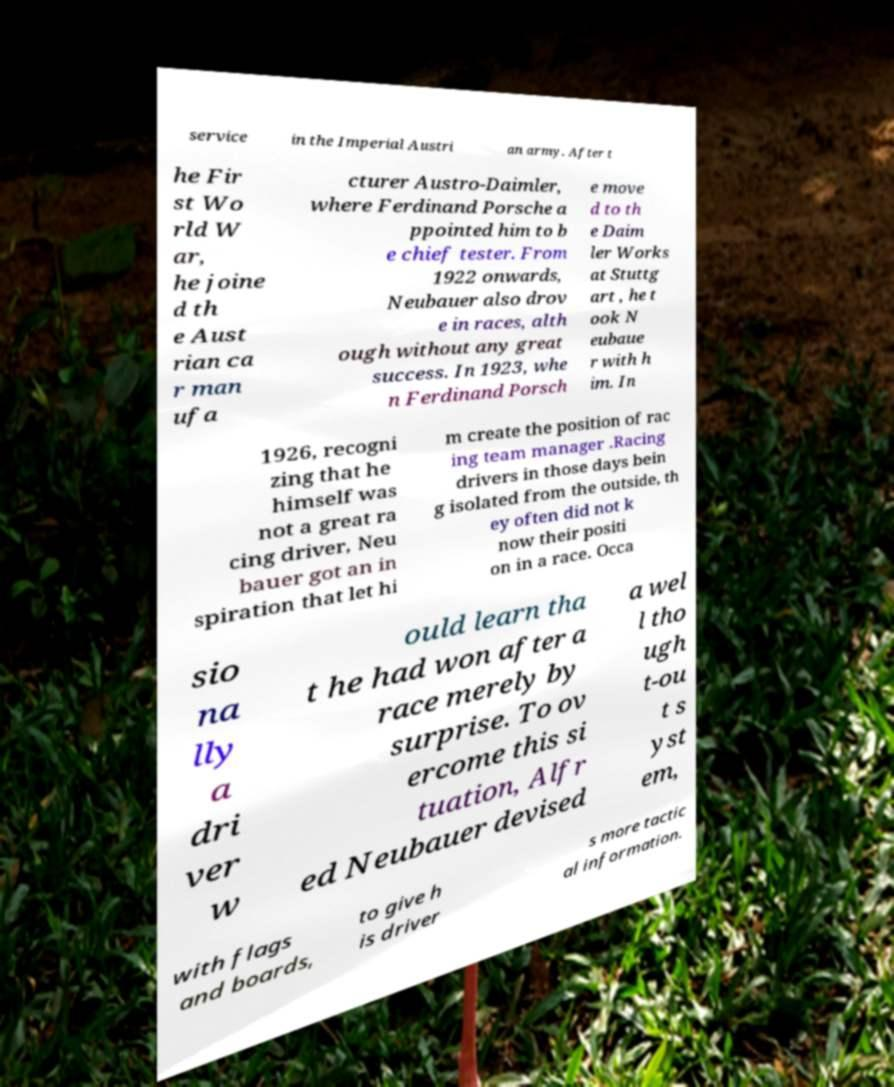There's text embedded in this image that I need extracted. Can you transcribe it verbatim? service in the Imperial Austri an army. After t he Fir st Wo rld W ar, he joine d th e Aust rian ca r man ufa cturer Austro-Daimler, where Ferdinand Porsche a ppointed him to b e chief tester. From 1922 onwards, Neubauer also drov e in races, alth ough without any great success. In 1923, whe n Ferdinand Porsch e move d to th e Daim ler Works at Stuttg art , he t ook N eubaue r with h im. In 1926, recogni zing that he himself was not a great ra cing driver, Neu bauer got an in spiration that let hi m create the position of rac ing team manager .Racing drivers in those days bein g isolated from the outside, th ey often did not k now their positi on in a race. Occa sio na lly a dri ver w ould learn tha t he had won after a race merely by surprise. To ov ercome this si tuation, Alfr ed Neubauer devised a wel l tho ugh t-ou t s yst em, with flags and boards, to give h is driver s more tactic al information. 